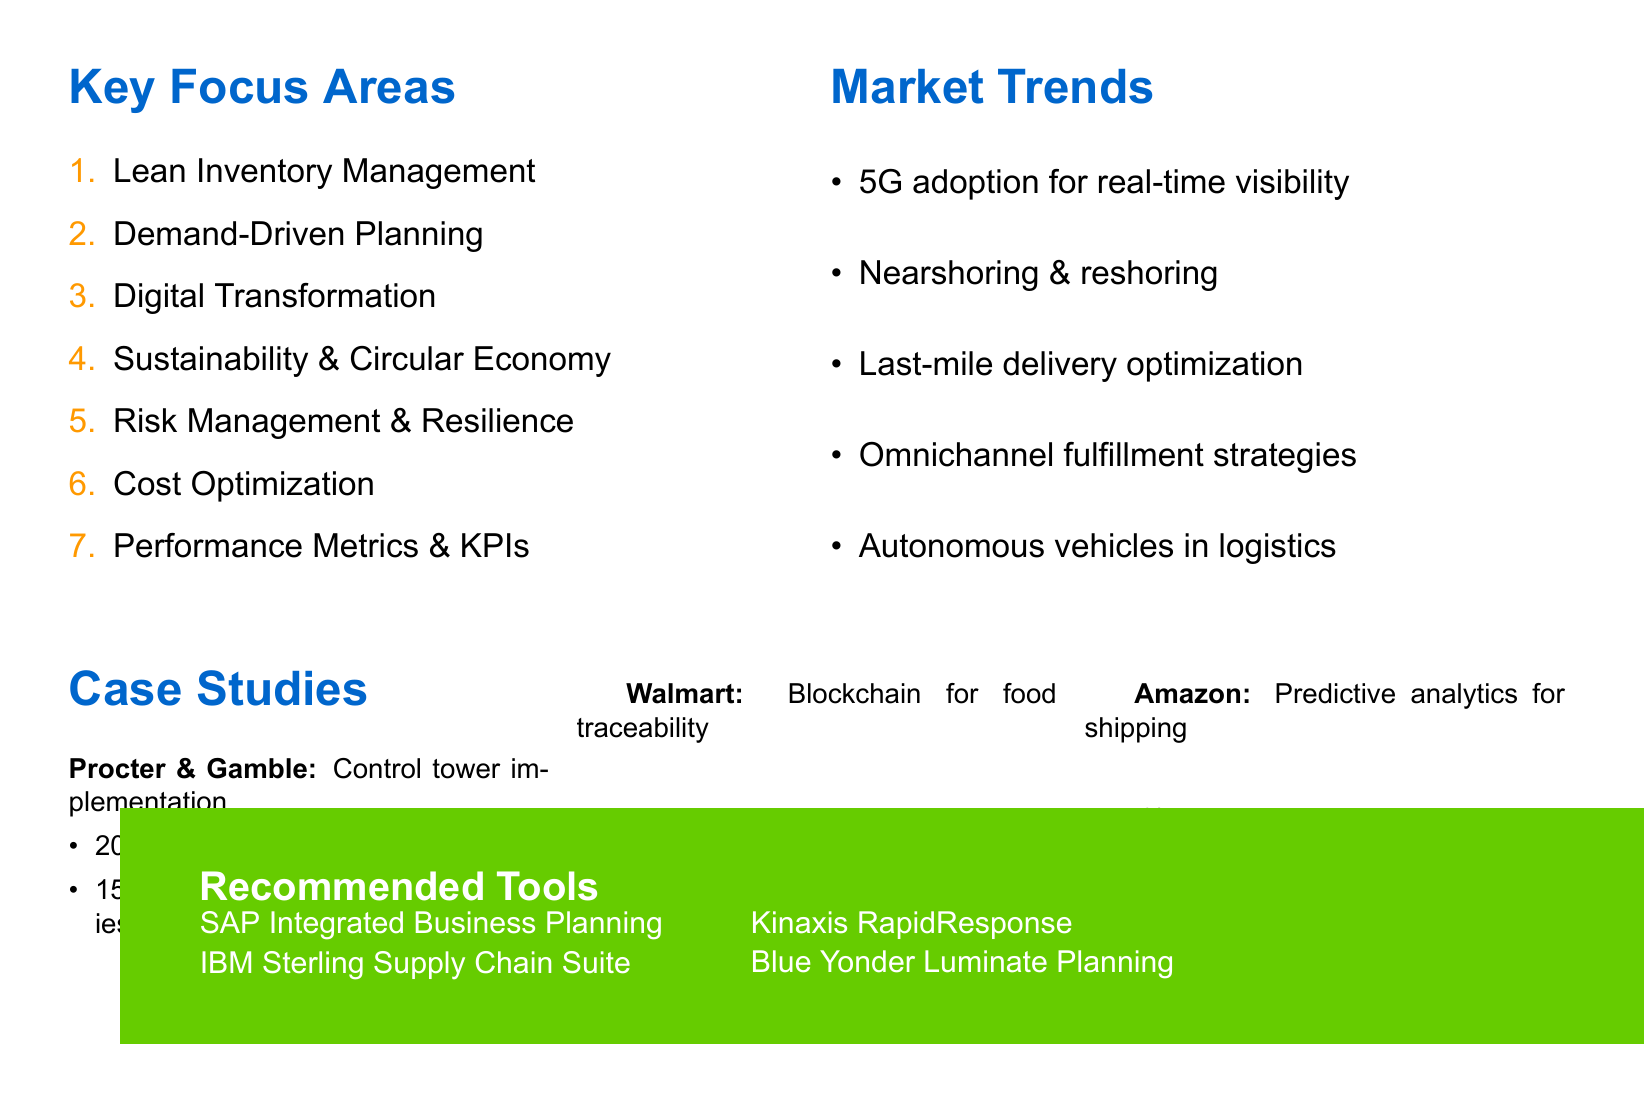What is the key focus area related to inventory management? The key focus area is explicitly listed in the agenda under key focus areas.
Answer: Lean Inventory Management What percentage of inventory cost reduction did Procter & Gamble achieve? The document states the results from the case study of Procter & Gamble, highlighting the reduction in inventory costs.
Answer: 20% Which company implemented blockchain for food traceability? This information is derived from the case studies section where Walmart is mentioned for this strategy.
Answer: Walmart What technology is increasingly being adopted for real-time supply chain visibility? The document explicitly mentions this technology among the market trends, making it a direct piece of information.
Answer: 5G technology What tool is recommended for end-to-end supply chain planning and optimization? The name of the tool is mentioned in the recommended tools section, providing clear identification.
Answer: SAP Integrated Business Planning What is one benefit of Vendor-managed inventory partnerships? This is an implicit benefit associated with lean inventory management practices in the agenda.
Answer: Improved inventory control Which company experienced improved customer satisfaction due to predictive analytics? The specific outcomes of the case study on Amazon indicate this result in the document.
Answer: Amazon What is a primary strategy in Demand-Driven Planning? The points listed under the Demand-Driven Planning section highlight this specific strategy.
Answer: Leveraging machine learning for demand forecasting accuracy 